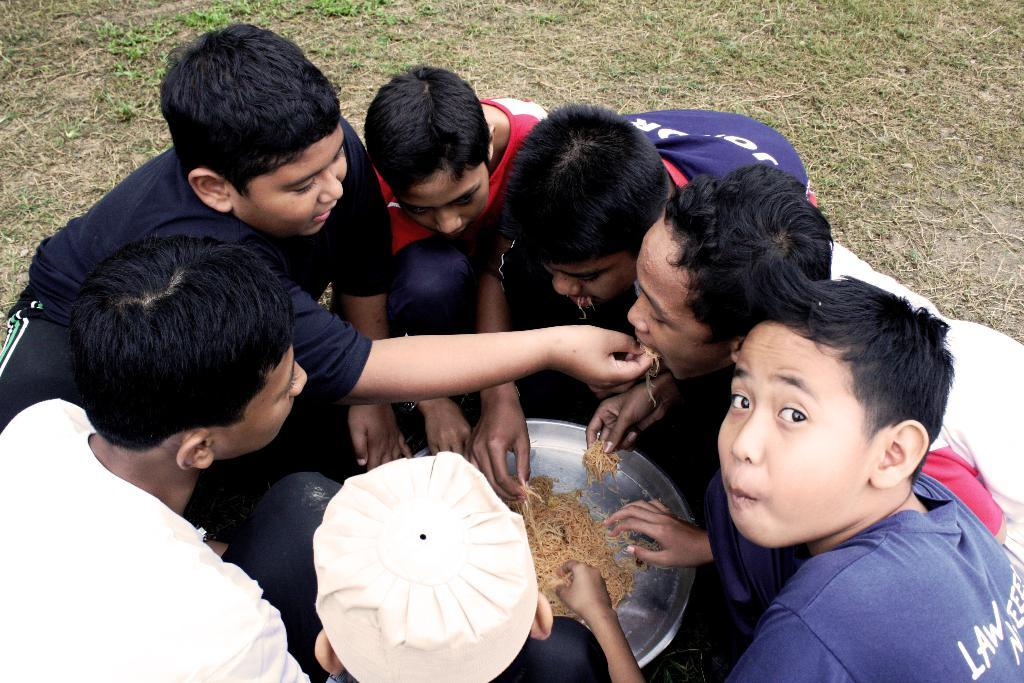What are the people in the image doing? The people in the image are sitting on the ground. What is in the middle of the people? There is a plate with food in the middle of the people. What type of bait is being used to catch fish in the image? There is no mention of fishing or bait in the image; it features people sitting on the ground with a plate of food in the middle. 